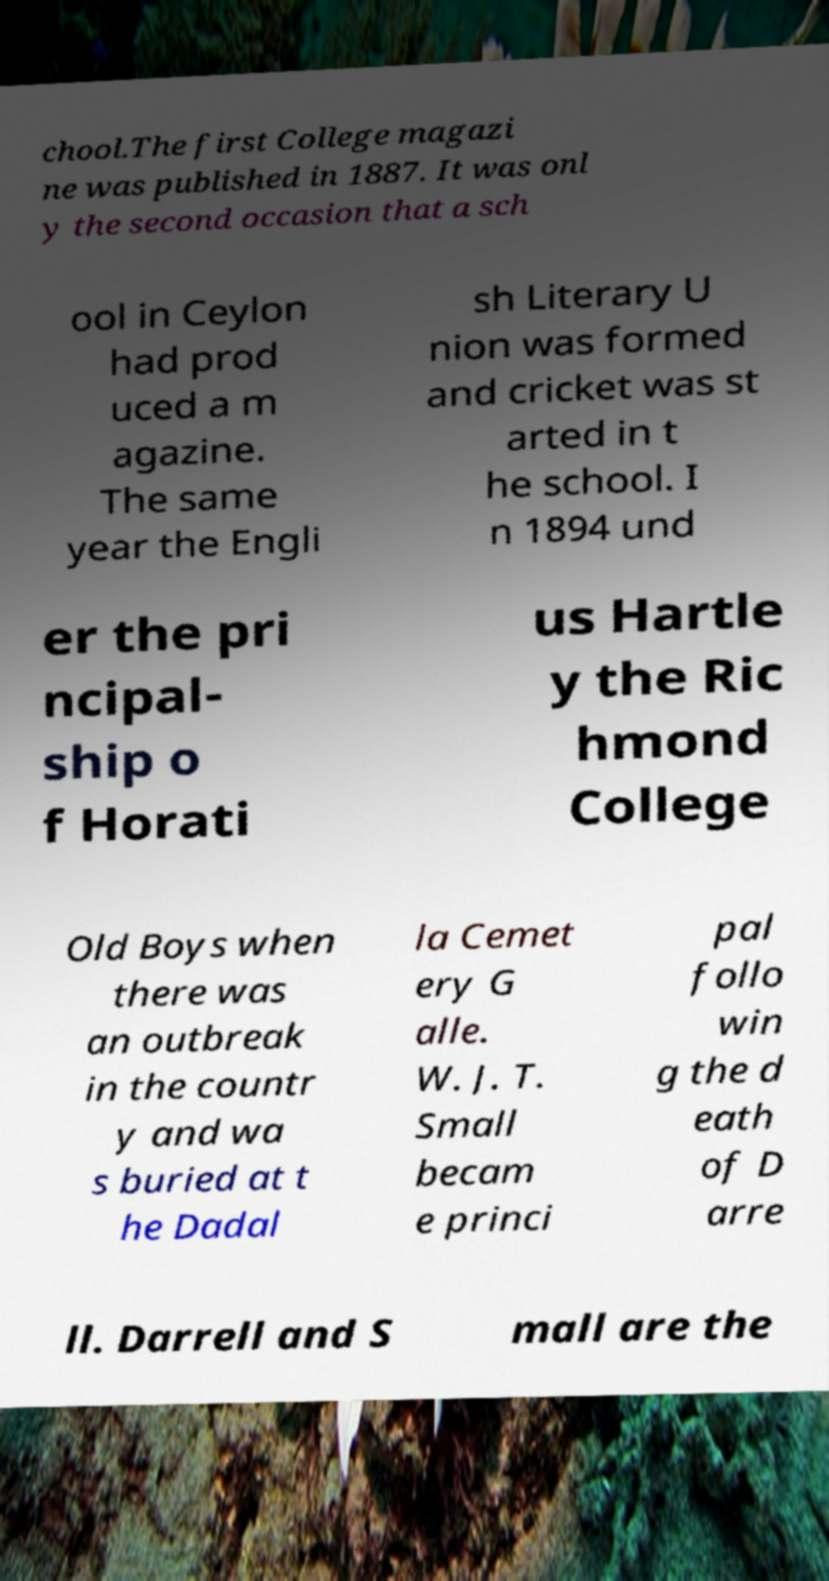Please read and relay the text visible in this image. What does it say? chool.The first College magazi ne was published in 1887. It was onl y the second occasion that a sch ool in Ceylon had prod uced a m agazine. The same year the Engli sh Literary U nion was formed and cricket was st arted in t he school. I n 1894 und er the pri ncipal- ship o f Horati us Hartle y the Ric hmond College Old Boys when there was an outbreak in the countr y and wa s buried at t he Dadal la Cemet ery G alle. W. J. T. Small becam e princi pal follo win g the d eath of D arre ll. Darrell and S mall are the 